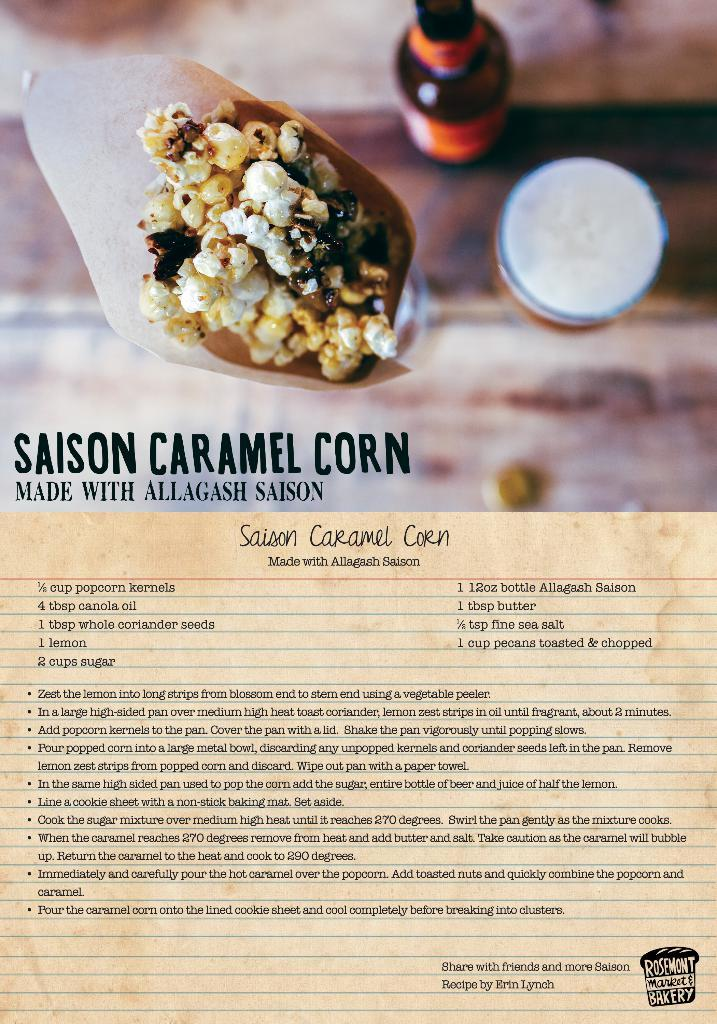<image>
Give a short and clear explanation of the subsequent image. The recipe for Saison caramel corn by Allagash Saison. 